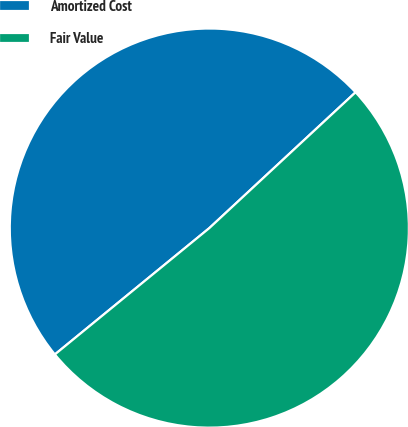<chart> <loc_0><loc_0><loc_500><loc_500><pie_chart><fcel>Amortized Cost<fcel>Fair Value<nl><fcel>49.0%<fcel>51.0%<nl></chart> 